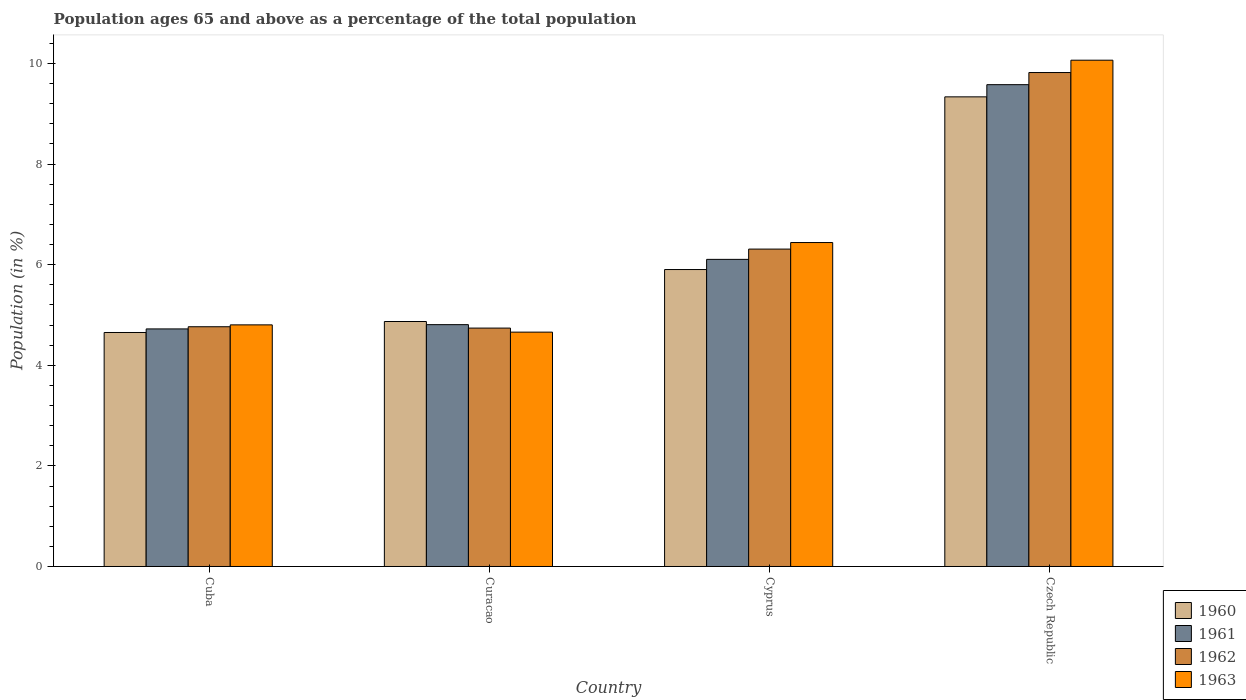How many different coloured bars are there?
Your response must be concise. 4. How many groups of bars are there?
Your answer should be compact. 4. Are the number of bars on each tick of the X-axis equal?
Offer a terse response. Yes. How many bars are there on the 4th tick from the right?
Give a very brief answer. 4. What is the label of the 3rd group of bars from the left?
Offer a very short reply. Cyprus. In how many cases, is the number of bars for a given country not equal to the number of legend labels?
Ensure brevity in your answer.  0. What is the percentage of the population ages 65 and above in 1960 in Cuba?
Your response must be concise. 4.65. Across all countries, what is the maximum percentage of the population ages 65 and above in 1962?
Provide a succinct answer. 9.82. Across all countries, what is the minimum percentage of the population ages 65 and above in 1963?
Provide a succinct answer. 4.66. In which country was the percentage of the population ages 65 and above in 1963 maximum?
Offer a terse response. Czech Republic. In which country was the percentage of the population ages 65 and above in 1960 minimum?
Your answer should be very brief. Cuba. What is the total percentage of the population ages 65 and above in 1960 in the graph?
Your answer should be compact. 24.76. What is the difference between the percentage of the population ages 65 and above in 1963 in Cuba and that in Cyprus?
Your answer should be very brief. -1.64. What is the difference between the percentage of the population ages 65 and above in 1961 in Curacao and the percentage of the population ages 65 and above in 1963 in Cyprus?
Your answer should be very brief. -1.63. What is the average percentage of the population ages 65 and above in 1960 per country?
Provide a succinct answer. 6.19. What is the difference between the percentage of the population ages 65 and above of/in 1962 and percentage of the population ages 65 and above of/in 1961 in Curacao?
Offer a terse response. -0.07. What is the ratio of the percentage of the population ages 65 and above in 1961 in Curacao to that in Czech Republic?
Your answer should be very brief. 0.5. Is the difference between the percentage of the population ages 65 and above in 1962 in Cyprus and Czech Republic greater than the difference between the percentage of the population ages 65 and above in 1961 in Cyprus and Czech Republic?
Your response must be concise. No. What is the difference between the highest and the second highest percentage of the population ages 65 and above in 1961?
Your response must be concise. 4.77. What is the difference between the highest and the lowest percentage of the population ages 65 and above in 1960?
Offer a terse response. 4.68. What does the 3rd bar from the left in Curacao represents?
Provide a short and direct response. 1962. What does the 2nd bar from the right in Curacao represents?
Offer a very short reply. 1962. How many bars are there?
Your answer should be compact. 16. How many countries are there in the graph?
Offer a very short reply. 4. What is the difference between two consecutive major ticks on the Y-axis?
Offer a very short reply. 2. Where does the legend appear in the graph?
Your answer should be compact. Bottom right. How are the legend labels stacked?
Offer a terse response. Vertical. What is the title of the graph?
Your answer should be compact. Population ages 65 and above as a percentage of the total population. Does "2010" appear as one of the legend labels in the graph?
Your response must be concise. No. What is the label or title of the Y-axis?
Make the answer very short. Population (in %). What is the Population (in %) in 1960 in Cuba?
Provide a succinct answer. 4.65. What is the Population (in %) in 1961 in Cuba?
Keep it short and to the point. 4.72. What is the Population (in %) of 1962 in Cuba?
Provide a succinct answer. 4.77. What is the Population (in %) in 1963 in Cuba?
Your response must be concise. 4.8. What is the Population (in %) of 1960 in Curacao?
Provide a succinct answer. 4.87. What is the Population (in %) in 1961 in Curacao?
Your answer should be very brief. 4.81. What is the Population (in %) in 1962 in Curacao?
Make the answer very short. 4.74. What is the Population (in %) of 1963 in Curacao?
Provide a succinct answer. 4.66. What is the Population (in %) of 1960 in Cyprus?
Provide a succinct answer. 5.9. What is the Population (in %) of 1961 in Cyprus?
Keep it short and to the point. 6.11. What is the Population (in %) in 1962 in Cyprus?
Ensure brevity in your answer.  6.31. What is the Population (in %) of 1963 in Cyprus?
Your answer should be very brief. 6.44. What is the Population (in %) of 1960 in Czech Republic?
Keep it short and to the point. 9.34. What is the Population (in %) in 1961 in Czech Republic?
Your response must be concise. 9.58. What is the Population (in %) in 1962 in Czech Republic?
Ensure brevity in your answer.  9.82. What is the Population (in %) in 1963 in Czech Republic?
Provide a succinct answer. 10.07. Across all countries, what is the maximum Population (in %) of 1960?
Your answer should be compact. 9.34. Across all countries, what is the maximum Population (in %) of 1961?
Your answer should be very brief. 9.58. Across all countries, what is the maximum Population (in %) in 1962?
Your answer should be very brief. 9.82. Across all countries, what is the maximum Population (in %) in 1963?
Provide a short and direct response. 10.07. Across all countries, what is the minimum Population (in %) of 1960?
Ensure brevity in your answer.  4.65. Across all countries, what is the minimum Population (in %) of 1961?
Your response must be concise. 4.72. Across all countries, what is the minimum Population (in %) in 1962?
Your answer should be very brief. 4.74. Across all countries, what is the minimum Population (in %) in 1963?
Keep it short and to the point. 4.66. What is the total Population (in %) in 1960 in the graph?
Keep it short and to the point. 24.76. What is the total Population (in %) of 1961 in the graph?
Offer a very short reply. 25.21. What is the total Population (in %) of 1962 in the graph?
Make the answer very short. 25.63. What is the total Population (in %) of 1963 in the graph?
Provide a short and direct response. 25.97. What is the difference between the Population (in %) of 1960 in Cuba and that in Curacao?
Provide a succinct answer. -0.22. What is the difference between the Population (in %) of 1961 in Cuba and that in Curacao?
Provide a short and direct response. -0.08. What is the difference between the Population (in %) of 1962 in Cuba and that in Curacao?
Give a very brief answer. 0.03. What is the difference between the Population (in %) of 1963 in Cuba and that in Curacao?
Your answer should be very brief. 0.14. What is the difference between the Population (in %) in 1960 in Cuba and that in Cyprus?
Make the answer very short. -1.25. What is the difference between the Population (in %) in 1961 in Cuba and that in Cyprus?
Give a very brief answer. -1.38. What is the difference between the Population (in %) of 1962 in Cuba and that in Cyprus?
Your answer should be very brief. -1.54. What is the difference between the Population (in %) of 1963 in Cuba and that in Cyprus?
Your response must be concise. -1.64. What is the difference between the Population (in %) in 1960 in Cuba and that in Czech Republic?
Offer a very short reply. -4.68. What is the difference between the Population (in %) in 1961 in Cuba and that in Czech Republic?
Provide a succinct answer. -4.86. What is the difference between the Population (in %) of 1962 in Cuba and that in Czech Republic?
Provide a short and direct response. -5.05. What is the difference between the Population (in %) in 1963 in Cuba and that in Czech Republic?
Give a very brief answer. -5.26. What is the difference between the Population (in %) of 1960 in Curacao and that in Cyprus?
Ensure brevity in your answer.  -1.03. What is the difference between the Population (in %) of 1961 in Curacao and that in Cyprus?
Provide a short and direct response. -1.3. What is the difference between the Population (in %) of 1962 in Curacao and that in Cyprus?
Make the answer very short. -1.57. What is the difference between the Population (in %) in 1963 in Curacao and that in Cyprus?
Make the answer very short. -1.78. What is the difference between the Population (in %) of 1960 in Curacao and that in Czech Republic?
Ensure brevity in your answer.  -4.47. What is the difference between the Population (in %) of 1961 in Curacao and that in Czech Republic?
Your answer should be very brief. -4.77. What is the difference between the Population (in %) of 1962 in Curacao and that in Czech Republic?
Your answer should be compact. -5.08. What is the difference between the Population (in %) in 1963 in Curacao and that in Czech Republic?
Provide a short and direct response. -5.41. What is the difference between the Population (in %) of 1960 in Cyprus and that in Czech Republic?
Provide a succinct answer. -3.43. What is the difference between the Population (in %) in 1961 in Cyprus and that in Czech Republic?
Your response must be concise. -3.47. What is the difference between the Population (in %) of 1962 in Cyprus and that in Czech Republic?
Ensure brevity in your answer.  -3.51. What is the difference between the Population (in %) of 1963 in Cyprus and that in Czech Republic?
Make the answer very short. -3.63. What is the difference between the Population (in %) of 1960 in Cuba and the Population (in %) of 1961 in Curacao?
Keep it short and to the point. -0.16. What is the difference between the Population (in %) of 1960 in Cuba and the Population (in %) of 1962 in Curacao?
Provide a succinct answer. -0.09. What is the difference between the Population (in %) of 1960 in Cuba and the Population (in %) of 1963 in Curacao?
Ensure brevity in your answer.  -0.01. What is the difference between the Population (in %) in 1961 in Cuba and the Population (in %) in 1962 in Curacao?
Offer a terse response. -0.02. What is the difference between the Population (in %) of 1961 in Cuba and the Population (in %) of 1963 in Curacao?
Your answer should be very brief. 0.06. What is the difference between the Population (in %) in 1962 in Cuba and the Population (in %) in 1963 in Curacao?
Your answer should be very brief. 0.11. What is the difference between the Population (in %) of 1960 in Cuba and the Population (in %) of 1961 in Cyprus?
Offer a terse response. -1.45. What is the difference between the Population (in %) in 1960 in Cuba and the Population (in %) in 1962 in Cyprus?
Ensure brevity in your answer.  -1.66. What is the difference between the Population (in %) in 1960 in Cuba and the Population (in %) in 1963 in Cyprus?
Offer a terse response. -1.79. What is the difference between the Population (in %) in 1961 in Cuba and the Population (in %) in 1962 in Cyprus?
Keep it short and to the point. -1.59. What is the difference between the Population (in %) of 1961 in Cuba and the Population (in %) of 1963 in Cyprus?
Provide a succinct answer. -1.72. What is the difference between the Population (in %) of 1962 in Cuba and the Population (in %) of 1963 in Cyprus?
Your answer should be compact. -1.67. What is the difference between the Population (in %) of 1960 in Cuba and the Population (in %) of 1961 in Czech Republic?
Give a very brief answer. -4.93. What is the difference between the Population (in %) in 1960 in Cuba and the Population (in %) in 1962 in Czech Republic?
Provide a short and direct response. -5.17. What is the difference between the Population (in %) of 1960 in Cuba and the Population (in %) of 1963 in Czech Republic?
Give a very brief answer. -5.41. What is the difference between the Population (in %) in 1961 in Cuba and the Population (in %) in 1962 in Czech Republic?
Offer a terse response. -5.1. What is the difference between the Population (in %) in 1961 in Cuba and the Population (in %) in 1963 in Czech Republic?
Make the answer very short. -5.34. What is the difference between the Population (in %) of 1962 in Cuba and the Population (in %) of 1963 in Czech Republic?
Make the answer very short. -5.3. What is the difference between the Population (in %) in 1960 in Curacao and the Population (in %) in 1961 in Cyprus?
Provide a succinct answer. -1.24. What is the difference between the Population (in %) in 1960 in Curacao and the Population (in %) in 1962 in Cyprus?
Offer a very short reply. -1.44. What is the difference between the Population (in %) in 1960 in Curacao and the Population (in %) in 1963 in Cyprus?
Your response must be concise. -1.57. What is the difference between the Population (in %) in 1961 in Curacao and the Population (in %) in 1962 in Cyprus?
Provide a succinct answer. -1.5. What is the difference between the Population (in %) in 1961 in Curacao and the Population (in %) in 1963 in Cyprus?
Ensure brevity in your answer.  -1.63. What is the difference between the Population (in %) of 1962 in Curacao and the Population (in %) of 1963 in Cyprus?
Offer a very short reply. -1.7. What is the difference between the Population (in %) in 1960 in Curacao and the Population (in %) in 1961 in Czech Republic?
Your answer should be very brief. -4.71. What is the difference between the Population (in %) in 1960 in Curacao and the Population (in %) in 1962 in Czech Republic?
Give a very brief answer. -4.95. What is the difference between the Population (in %) of 1960 in Curacao and the Population (in %) of 1963 in Czech Republic?
Keep it short and to the point. -5.2. What is the difference between the Population (in %) in 1961 in Curacao and the Population (in %) in 1962 in Czech Republic?
Ensure brevity in your answer.  -5.01. What is the difference between the Population (in %) of 1961 in Curacao and the Population (in %) of 1963 in Czech Republic?
Your answer should be compact. -5.26. What is the difference between the Population (in %) in 1962 in Curacao and the Population (in %) in 1963 in Czech Republic?
Provide a succinct answer. -5.33. What is the difference between the Population (in %) of 1960 in Cyprus and the Population (in %) of 1961 in Czech Republic?
Provide a short and direct response. -3.68. What is the difference between the Population (in %) of 1960 in Cyprus and the Population (in %) of 1962 in Czech Republic?
Offer a terse response. -3.92. What is the difference between the Population (in %) in 1960 in Cyprus and the Population (in %) in 1963 in Czech Republic?
Make the answer very short. -4.16. What is the difference between the Population (in %) in 1961 in Cyprus and the Population (in %) in 1962 in Czech Republic?
Make the answer very short. -3.71. What is the difference between the Population (in %) in 1961 in Cyprus and the Population (in %) in 1963 in Czech Republic?
Your response must be concise. -3.96. What is the difference between the Population (in %) of 1962 in Cyprus and the Population (in %) of 1963 in Czech Republic?
Keep it short and to the point. -3.76. What is the average Population (in %) in 1960 per country?
Your response must be concise. 6.19. What is the average Population (in %) of 1961 per country?
Provide a short and direct response. 6.3. What is the average Population (in %) in 1962 per country?
Provide a succinct answer. 6.41. What is the average Population (in %) of 1963 per country?
Your response must be concise. 6.49. What is the difference between the Population (in %) of 1960 and Population (in %) of 1961 in Cuba?
Give a very brief answer. -0.07. What is the difference between the Population (in %) in 1960 and Population (in %) in 1962 in Cuba?
Your response must be concise. -0.11. What is the difference between the Population (in %) of 1960 and Population (in %) of 1963 in Cuba?
Provide a short and direct response. -0.15. What is the difference between the Population (in %) in 1961 and Population (in %) in 1962 in Cuba?
Make the answer very short. -0.04. What is the difference between the Population (in %) of 1961 and Population (in %) of 1963 in Cuba?
Offer a terse response. -0.08. What is the difference between the Population (in %) in 1962 and Population (in %) in 1963 in Cuba?
Ensure brevity in your answer.  -0.04. What is the difference between the Population (in %) in 1960 and Population (in %) in 1961 in Curacao?
Your answer should be compact. 0.06. What is the difference between the Population (in %) in 1960 and Population (in %) in 1962 in Curacao?
Your answer should be compact. 0.13. What is the difference between the Population (in %) of 1960 and Population (in %) of 1963 in Curacao?
Give a very brief answer. 0.21. What is the difference between the Population (in %) of 1961 and Population (in %) of 1962 in Curacao?
Your answer should be very brief. 0.07. What is the difference between the Population (in %) in 1961 and Population (in %) in 1963 in Curacao?
Offer a terse response. 0.15. What is the difference between the Population (in %) of 1962 and Population (in %) of 1963 in Curacao?
Provide a short and direct response. 0.08. What is the difference between the Population (in %) of 1960 and Population (in %) of 1961 in Cyprus?
Your answer should be very brief. -0.2. What is the difference between the Population (in %) in 1960 and Population (in %) in 1962 in Cyprus?
Keep it short and to the point. -0.41. What is the difference between the Population (in %) in 1960 and Population (in %) in 1963 in Cyprus?
Offer a very short reply. -0.54. What is the difference between the Population (in %) in 1961 and Population (in %) in 1962 in Cyprus?
Provide a succinct answer. -0.2. What is the difference between the Population (in %) in 1961 and Population (in %) in 1963 in Cyprus?
Provide a short and direct response. -0.33. What is the difference between the Population (in %) of 1962 and Population (in %) of 1963 in Cyprus?
Give a very brief answer. -0.13. What is the difference between the Population (in %) of 1960 and Population (in %) of 1961 in Czech Republic?
Offer a very short reply. -0.24. What is the difference between the Population (in %) of 1960 and Population (in %) of 1962 in Czech Republic?
Your answer should be very brief. -0.48. What is the difference between the Population (in %) in 1960 and Population (in %) in 1963 in Czech Republic?
Your answer should be very brief. -0.73. What is the difference between the Population (in %) in 1961 and Population (in %) in 1962 in Czech Republic?
Your answer should be very brief. -0.24. What is the difference between the Population (in %) of 1961 and Population (in %) of 1963 in Czech Republic?
Ensure brevity in your answer.  -0.49. What is the difference between the Population (in %) of 1962 and Population (in %) of 1963 in Czech Republic?
Give a very brief answer. -0.25. What is the ratio of the Population (in %) of 1960 in Cuba to that in Curacao?
Provide a succinct answer. 0.96. What is the ratio of the Population (in %) in 1961 in Cuba to that in Curacao?
Your answer should be very brief. 0.98. What is the ratio of the Population (in %) of 1962 in Cuba to that in Curacao?
Ensure brevity in your answer.  1.01. What is the ratio of the Population (in %) in 1963 in Cuba to that in Curacao?
Give a very brief answer. 1.03. What is the ratio of the Population (in %) in 1960 in Cuba to that in Cyprus?
Provide a succinct answer. 0.79. What is the ratio of the Population (in %) of 1961 in Cuba to that in Cyprus?
Offer a very short reply. 0.77. What is the ratio of the Population (in %) of 1962 in Cuba to that in Cyprus?
Your answer should be compact. 0.76. What is the ratio of the Population (in %) in 1963 in Cuba to that in Cyprus?
Provide a succinct answer. 0.75. What is the ratio of the Population (in %) of 1960 in Cuba to that in Czech Republic?
Offer a very short reply. 0.5. What is the ratio of the Population (in %) of 1961 in Cuba to that in Czech Republic?
Your answer should be compact. 0.49. What is the ratio of the Population (in %) of 1962 in Cuba to that in Czech Republic?
Your response must be concise. 0.49. What is the ratio of the Population (in %) in 1963 in Cuba to that in Czech Republic?
Ensure brevity in your answer.  0.48. What is the ratio of the Population (in %) of 1960 in Curacao to that in Cyprus?
Your answer should be very brief. 0.82. What is the ratio of the Population (in %) of 1961 in Curacao to that in Cyprus?
Provide a succinct answer. 0.79. What is the ratio of the Population (in %) of 1962 in Curacao to that in Cyprus?
Keep it short and to the point. 0.75. What is the ratio of the Population (in %) in 1963 in Curacao to that in Cyprus?
Provide a short and direct response. 0.72. What is the ratio of the Population (in %) in 1960 in Curacao to that in Czech Republic?
Make the answer very short. 0.52. What is the ratio of the Population (in %) in 1961 in Curacao to that in Czech Republic?
Offer a very short reply. 0.5. What is the ratio of the Population (in %) of 1962 in Curacao to that in Czech Republic?
Provide a short and direct response. 0.48. What is the ratio of the Population (in %) of 1963 in Curacao to that in Czech Republic?
Keep it short and to the point. 0.46. What is the ratio of the Population (in %) of 1960 in Cyprus to that in Czech Republic?
Your response must be concise. 0.63. What is the ratio of the Population (in %) in 1961 in Cyprus to that in Czech Republic?
Offer a terse response. 0.64. What is the ratio of the Population (in %) in 1962 in Cyprus to that in Czech Republic?
Make the answer very short. 0.64. What is the ratio of the Population (in %) of 1963 in Cyprus to that in Czech Republic?
Your response must be concise. 0.64. What is the difference between the highest and the second highest Population (in %) in 1960?
Provide a succinct answer. 3.43. What is the difference between the highest and the second highest Population (in %) of 1961?
Your answer should be very brief. 3.47. What is the difference between the highest and the second highest Population (in %) in 1962?
Offer a terse response. 3.51. What is the difference between the highest and the second highest Population (in %) in 1963?
Give a very brief answer. 3.63. What is the difference between the highest and the lowest Population (in %) of 1960?
Provide a succinct answer. 4.68. What is the difference between the highest and the lowest Population (in %) of 1961?
Make the answer very short. 4.86. What is the difference between the highest and the lowest Population (in %) of 1962?
Your answer should be very brief. 5.08. What is the difference between the highest and the lowest Population (in %) of 1963?
Provide a short and direct response. 5.41. 